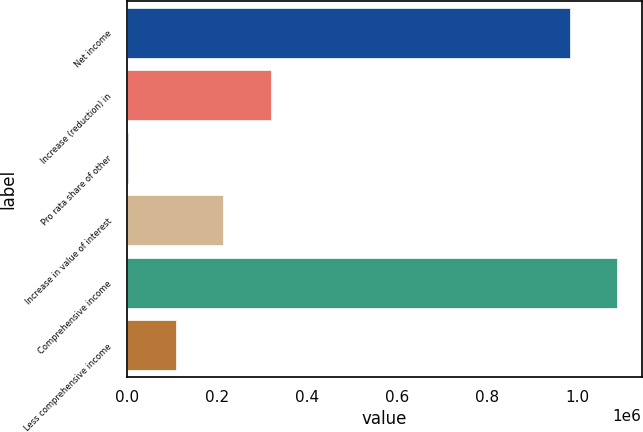Convert chart to OTSL. <chart><loc_0><loc_0><loc_500><loc_500><bar_chart><fcel>Net income<fcel>Increase (reduction) in<fcel>Pro rata share of other<fcel>Increase in value of interest<fcel>Comprehensive income<fcel>Less comprehensive income<nl><fcel>981922<fcel>319519<fcel>2739<fcel>213926<fcel>1.08752e+06<fcel>108332<nl></chart> 